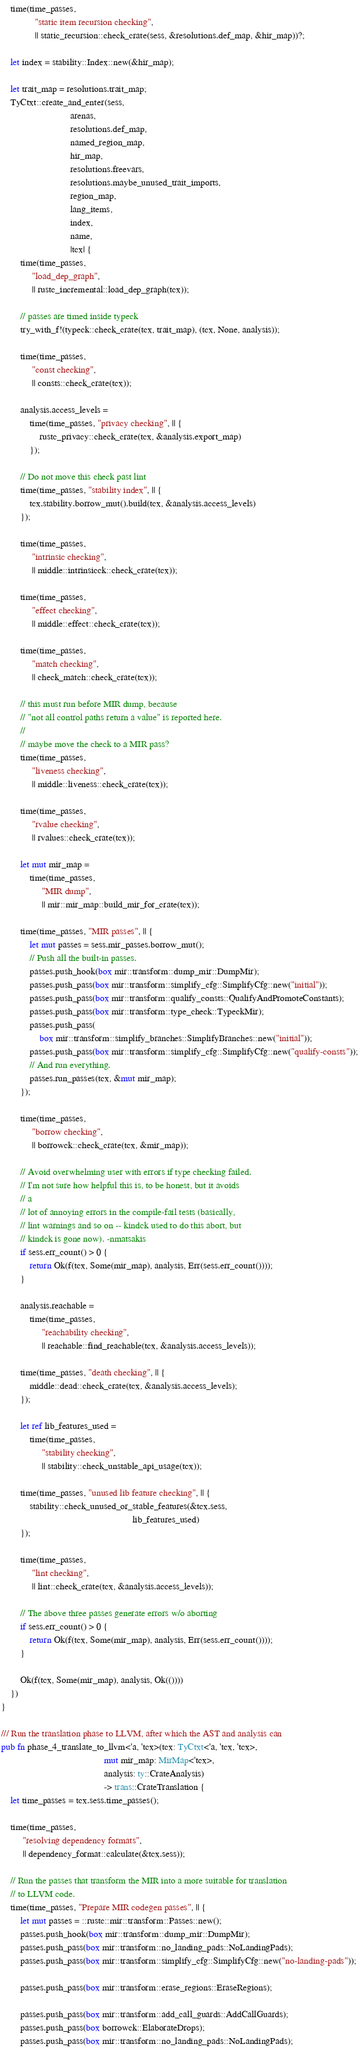<code> <loc_0><loc_0><loc_500><loc_500><_Rust_>    time(time_passes,
              "static item recursion checking",
              || static_recursion::check_crate(sess, &resolutions.def_map, &hir_map))?;

    let index = stability::Index::new(&hir_map);

    let trait_map = resolutions.trait_map;
    TyCtxt::create_and_enter(sess,
                             arenas,
                             resolutions.def_map,
                             named_region_map,
                             hir_map,
                             resolutions.freevars,
                             resolutions.maybe_unused_trait_imports,
                             region_map,
                             lang_items,
                             index,
                             name,
                             |tcx| {
        time(time_passes,
             "load_dep_graph",
             || rustc_incremental::load_dep_graph(tcx));

        // passes are timed inside typeck
        try_with_f!(typeck::check_crate(tcx, trait_map), (tcx, None, analysis));

        time(time_passes,
             "const checking",
             || consts::check_crate(tcx));

        analysis.access_levels =
            time(time_passes, "privacy checking", || {
                rustc_privacy::check_crate(tcx, &analysis.export_map)
            });

        // Do not move this check past lint
        time(time_passes, "stability index", || {
            tcx.stability.borrow_mut().build(tcx, &analysis.access_levels)
        });

        time(time_passes,
             "intrinsic checking",
             || middle::intrinsicck::check_crate(tcx));

        time(time_passes,
             "effect checking",
             || middle::effect::check_crate(tcx));

        time(time_passes,
             "match checking",
             || check_match::check_crate(tcx));

        // this must run before MIR dump, because
        // "not all control paths return a value" is reported here.
        //
        // maybe move the check to a MIR pass?
        time(time_passes,
             "liveness checking",
             || middle::liveness::check_crate(tcx));

        time(time_passes,
             "rvalue checking",
             || rvalues::check_crate(tcx));

        let mut mir_map =
            time(time_passes,
                 "MIR dump",
                 || mir::mir_map::build_mir_for_crate(tcx));

        time(time_passes, "MIR passes", || {
            let mut passes = sess.mir_passes.borrow_mut();
            // Push all the built-in passes.
            passes.push_hook(box mir::transform::dump_mir::DumpMir);
            passes.push_pass(box mir::transform::simplify_cfg::SimplifyCfg::new("initial"));
            passes.push_pass(box mir::transform::qualify_consts::QualifyAndPromoteConstants);
            passes.push_pass(box mir::transform::type_check::TypeckMir);
            passes.push_pass(
                box mir::transform::simplify_branches::SimplifyBranches::new("initial"));
            passes.push_pass(box mir::transform::simplify_cfg::SimplifyCfg::new("qualify-consts"));
            // And run everything.
            passes.run_passes(tcx, &mut mir_map);
        });

        time(time_passes,
             "borrow checking",
             || borrowck::check_crate(tcx, &mir_map));

        // Avoid overwhelming user with errors if type checking failed.
        // I'm not sure how helpful this is, to be honest, but it avoids
        // a
        // lot of annoying errors in the compile-fail tests (basically,
        // lint warnings and so on -- kindck used to do this abort, but
        // kindck is gone now). -nmatsakis
        if sess.err_count() > 0 {
            return Ok(f(tcx, Some(mir_map), analysis, Err(sess.err_count())));
        }

        analysis.reachable =
            time(time_passes,
                 "reachability checking",
                 || reachable::find_reachable(tcx, &analysis.access_levels));

        time(time_passes, "death checking", || {
            middle::dead::check_crate(tcx, &analysis.access_levels);
        });

        let ref lib_features_used =
            time(time_passes,
                 "stability checking",
                 || stability::check_unstable_api_usage(tcx));

        time(time_passes, "unused lib feature checking", || {
            stability::check_unused_or_stable_features(&tcx.sess,
                                                       lib_features_used)
        });

        time(time_passes,
             "lint checking",
             || lint::check_crate(tcx, &analysis.access_levels));

        // The above three passes generate errors w/o aborting
        if sess.err_count() > 0 {
            return Ok(f(tcx, Some(mir_map), analysis, Err(sess.err_count())));
        }

        Ok(f(tcx, Some(mir_map), analysis, Ok(())))
    })
}

/// Run the translation phase to LLVM, after which the AST and analysis can
pub fn phase_4_translate_to_llvm<'a, 'tcx>(tcx: TyCtxt<'a, 'tcx, 'tcx>,
                                           mut mir_map: MirMap<'tcx>,
                                           analysis: ty::CrateAnalysis)
                                           -> trans::CrateTranslation {
    let time_passes = tcx.sess.time_passes();

    time(time_passes,
         "resolving dependency formats",
         || dependency_format::calculate(&tcx.sess));

    // Run the passes that transform the MIR into a more suitable for translation
    // to LLVM code.
    time(time_passes, "Prepare MIR codegen passes", || {
        let mut passes = ::rustc::mir::transform::Passes::new();
        passes.push_hook(box mir::transform::dump_mir::DumpMir);
        passes.push_pass(box mir::transform::no_landing_pads::NoLandingPads);
        passes.push_pass(box mir::transform::simplify_cfg::SimplifyCfg::new("no-landing-pads"));

        passes.push_pass(box mir::transform::erase_regions::EraseRegions);

        passes.push_pass(box mir::transform::add_call_guards::AddCallGuards);
        passes.push_pass(box borrowck::ElaborateDrops);
        passes.push_pass(box mir::transform::no_landing_pads::NoLandingPads);</code> 